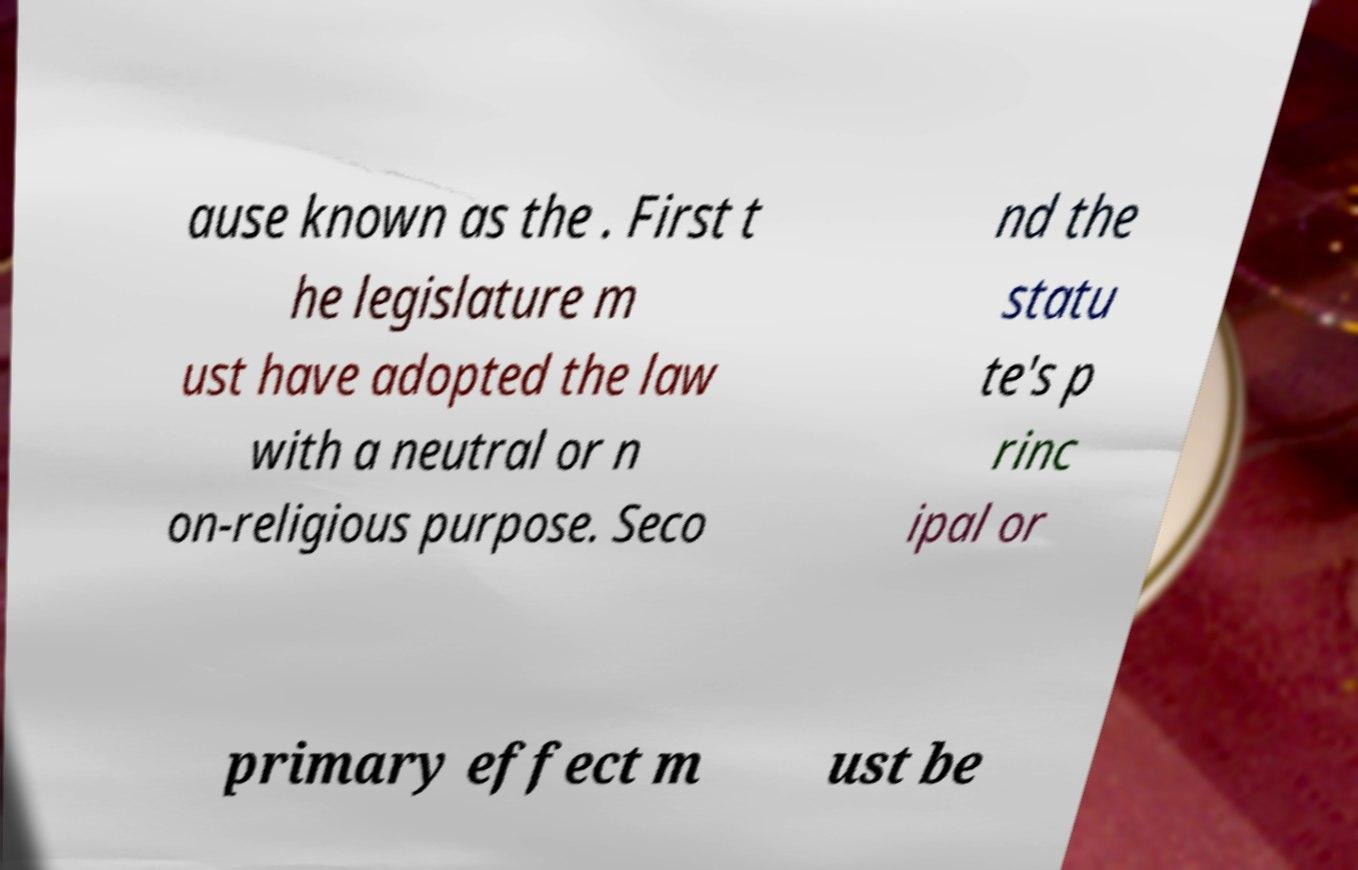I need the written content from this picture converted into text. Can you do that? ause known as the . First t he legislature m ust have adopted the law with a neutral or n on-religious purpose. Seco nd the statu te's p rinc ipal or primary effect m ust be 